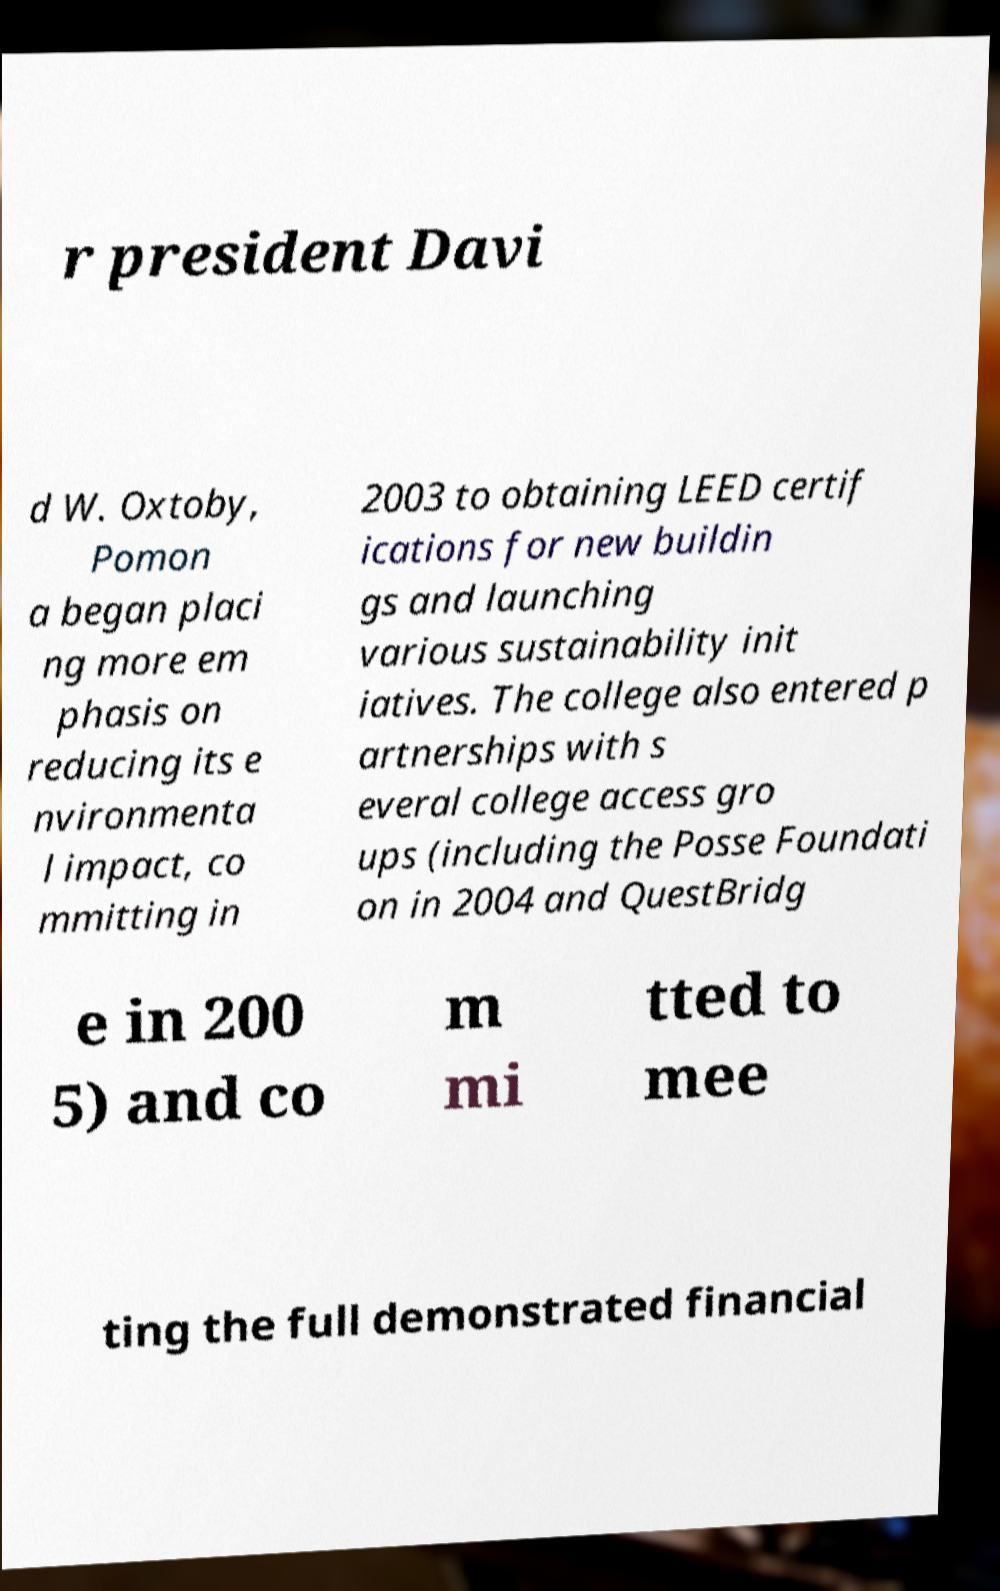There's text embedded in this image that I need extracted. Can you transcribe it verbatim? r president Davi d W. Oxtoby, Pomon a began placi ng more em phasis on reducing its e nvironmenta l impact, co mmitting in 2003 to obtaining LEED certif ications for new buildin gs and launching various sustainability init iatives. The college also entered p artnerships with s everal college access gro ups (including the Posse Foundati on in 2004 and QuestBridg e in 200 5) and co m mi tted to mee ting the full demonstrated financial 